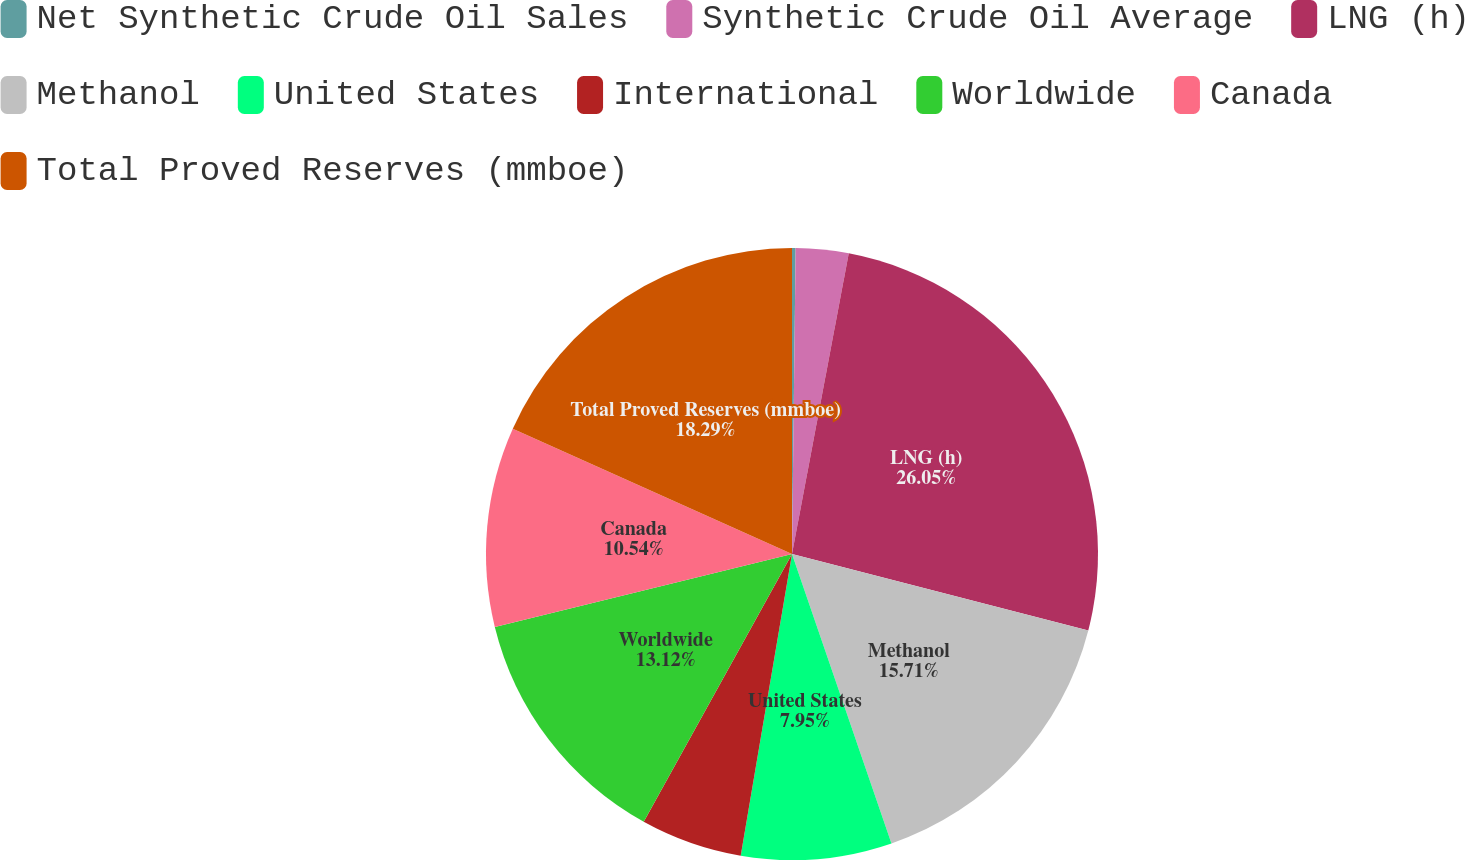Convert chart. <chart><loc_0><loc_0><loc_500><loc_500><pie_chart><fcel>Net Synthetic Crude Oil Sales<fcel>Synthetic Crude Oil Average<fcel>LNG (h)<fcel>Methanol<fcel>United States<fcel>International<fcel>Worldwide<fcel>Canada<fcel>Total Proved Reserves (mmboe)<nl><fcel>0.19%<fcel>2.78%<fcel>26.05%<fcel>15.71%<fcel>7.95%<fcel>5.37%<fcel>13.12%<fcel>10.54%<fcel>18.29%<nl></chart> 